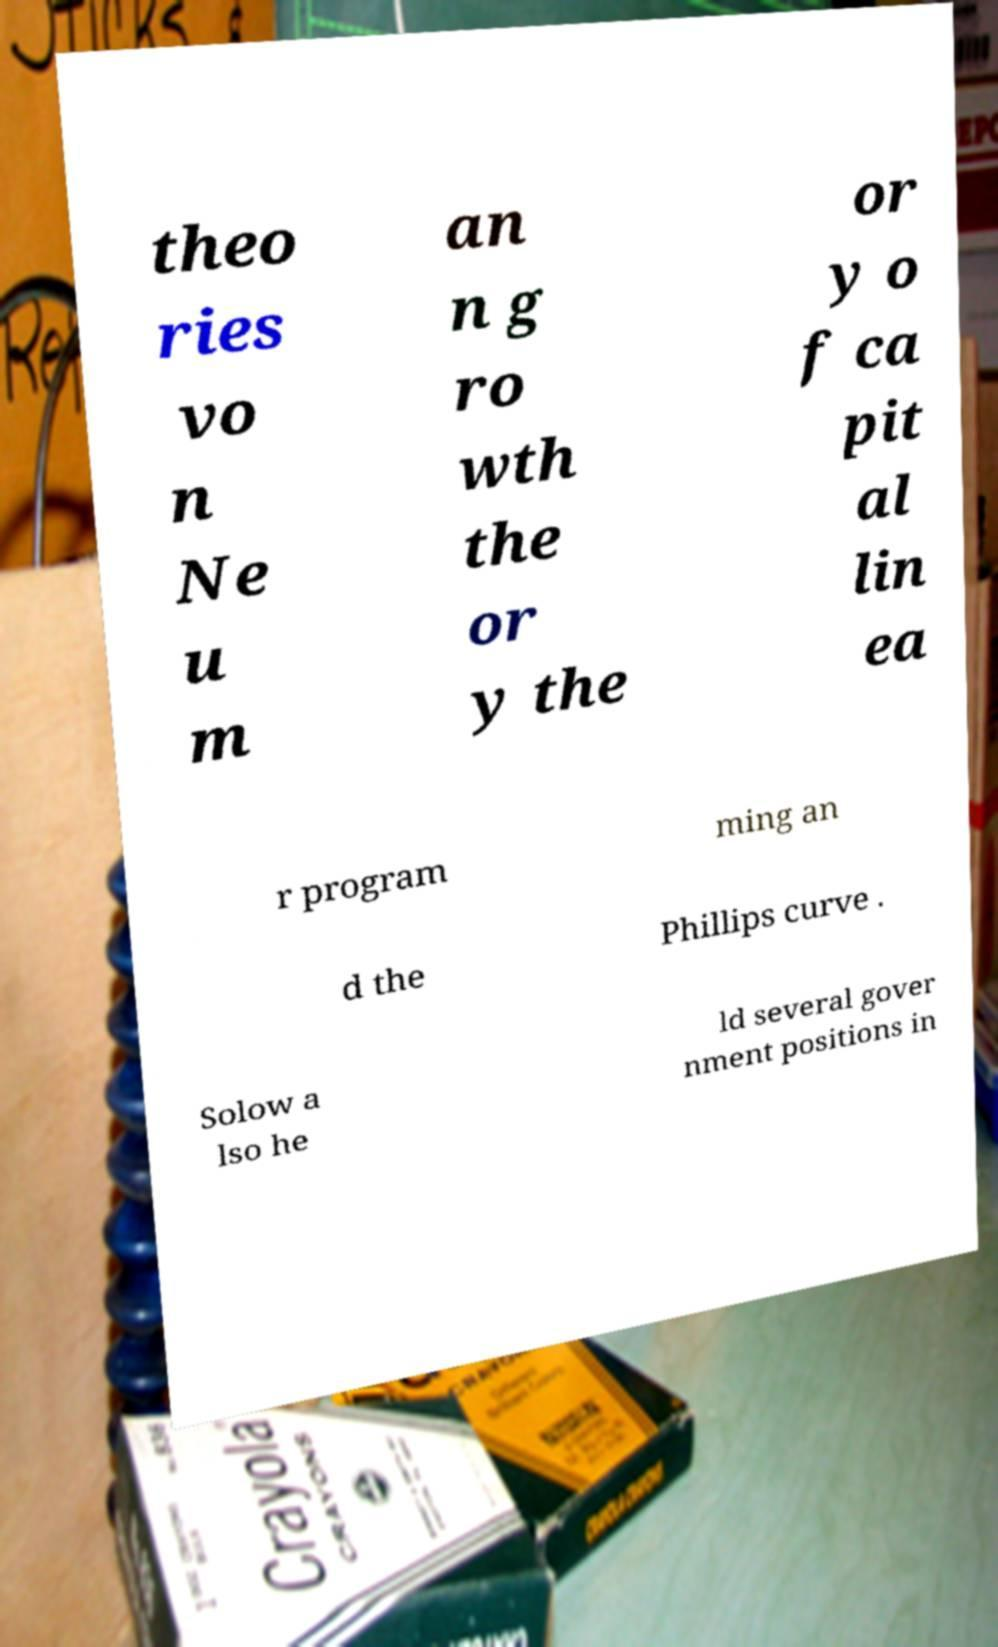Could you extract and type out the text from this image? theo ries vo n Ne u m an n g ro wth the or y the or y o f ca pit al lin ea r program ming an d the Phillips curve . Solow a lso he ld several gover nment positions in 